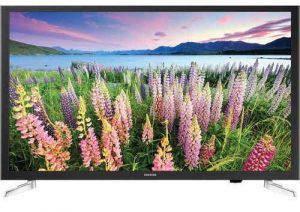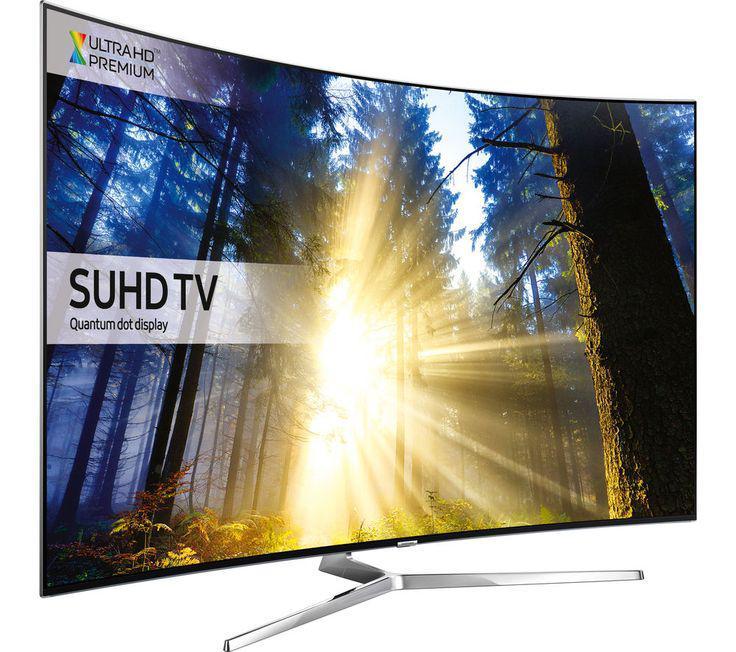The first image is the image on the left, the second image is the image on the right. Given the left and right images, does the statement "One of the TVs has flowers on the display." hold true? Answer yes or no. Yes. The first image is the image on the left, the second image is the image on the right. For the images displayed, is the sentence "A TV shows picture quality by displaying a picture of pink flowers beneath sky with clouds." factually correct? Answer yes or no. Yes. 